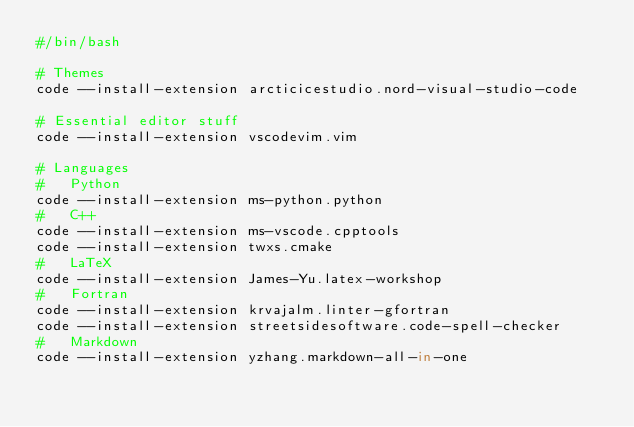Convert code to text. <code><loc_0><loc_0><loc_500><loc_500><_Bash_>#/bin/bash

# Themes
code --install-extension arcticicestudio.nord-visual-studio-code

# Essential editor stuff
code --install-extension vscodevim.vim

# Languages
#   Python
code --install-extension ms-python.python
#   C++
code --install-extension ms-vscode.cpptools
code --install-extension twxs.cmake
#   LaTeX
code --install-extension James-Yu.latex-workshop
#   Fortran
code --install-extension krvajalm.linter-gfortran
code --install-extension streetsidesoftware.code-spell-checker
#   Markdown
code --install-extension yzhang.markdown-all-in-one
</code> 